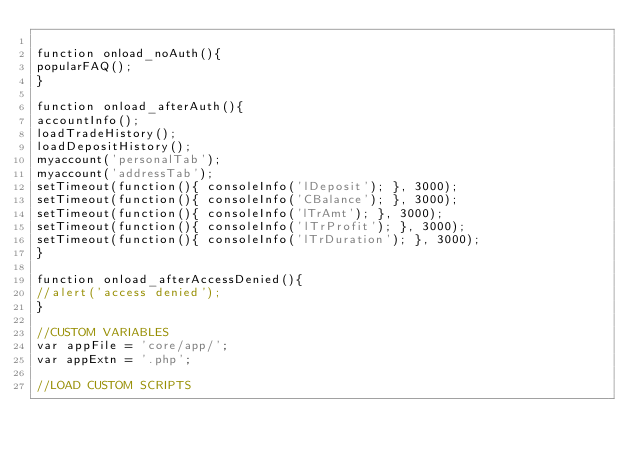<code> <loc_0><loc_0><loc_500><loc_500><_JavaScript_>
function onload_noAuth(){
popularFAQ();
}

function onload_afterAuth(){
accountInfo();
loadTradeHistory();
loadDepositHistory();
myaccount('personalTab');
myaccount('addressTab');
setTimeout(function(){ consoleInfo('lDeposit'); }, 3000);
setTimeout(function(){ consoleInfo('CBalance'); }, 3000);
setTimeout(function(){ consoleInfo('lTrAmt'); }, 3000);
setTimeout(function(){ consoleInfo('lTrProfit'); }, 3000);
setTimeout(function(){ consoleInfo('lTrDuration'); }, 3000);
}

function onload_afterAccessDenied(){
//alert('access denied');
}

//CUSTOM VARIABLES
var appFile = 'core/app/';
var appExtn = '.php';

//LOAD CUSTOM SCRIPTS</code> 